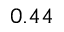<formula> <loc_0><loc_0><loc_500><loc_500>0 . 4 4</formula> 